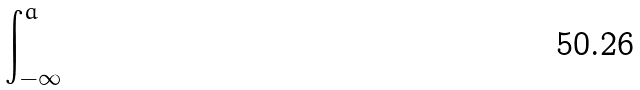<formula> <loc_0><loc_0><loc_500><loc_500>\int _ { - \infty } ^ { a }</formula> 